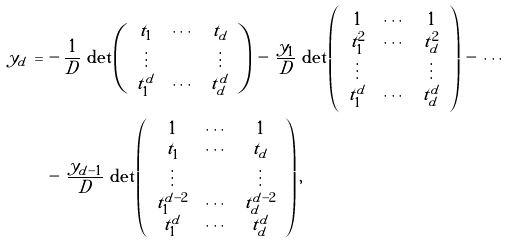Convert formula to latex. <formula><loc_0><loc_0><loc_500><loc_500>y _ { d } \, = \, & - \frac { 1 } { D } \, \det \left ( \begin{array} { c c c } t _ { 1 } & \cdots & t _ { d } \\ \vdots & & \vdots \\ t _ { 1 } ^ { d } & \cdots & t _ { d } ^ { d } \end{array} \right ) \, - \, \frac { y _ { 1 } } D \, \det \left ( \begin{array} { c c c } 1 & \cdots & 1 \\ t _ { 1 } ^ { 2 } & \cdots & t _ { d } ^ { 2 } \\ \vdots & & \vdots \\ t _ { 1 } ^ { d } & \cdots & t _ { d } ^ { d } \end{array} \right ) \, - \, \cdots \\ & - \, \frac { y _ { d - 1 } } D \, \det \left ( \begin{array} { c c c } 1 & \cdots & 1 \\ t _ { 1 } & \cdots & t _ { d } \\ \vdots & & \vdots \\ t _ { 1 } ^ { d - 2 } & \cdots & t _ { d } ^ { d - 2 } \\ t _ { 1 } ^ { d } & \cdots & t _ { d } ^ { d } \end{array} \right ) ,</formula> 